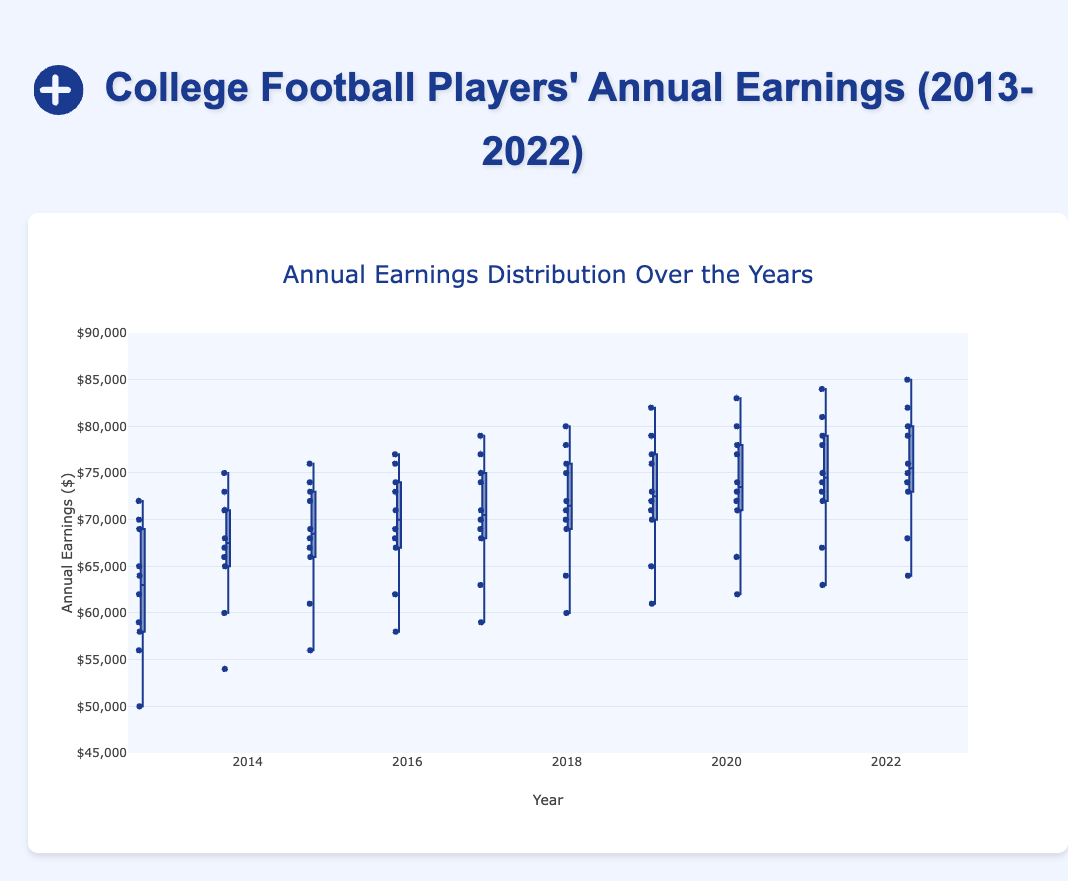What is the title of the figure? The title of the figure is found at the top. It reads "Annual Earnings Distribution Over the Years."
Answer: Annual Earnings Distribution Over the Years What is the range of the y-axis? The y-axis range is provided in the chart's layout and spans from a low value to a high value. In this case, it ranges from $45,000 to $90,000.
Answer: $45,000 to $90,000 How does the median annual earning for 2013 compare to 2022? The median is represented by the line inside each box. Viewing the boxes for 2013 and 2022, we can see that the median for 2013 is lower compared to 2022's median.
Answer: 2013 is lower than 2022 Which year has the highest upper whisker value? The upper whisker represents the maximum non-outlier value. By comparing all the upper whiskers, 2022 reaches the highest value.
Answer: 2022 What is the median annual earning for 2021? The median annual earning for each year is shown by the line inside each box. For 2021, the median is where the line divides the box.
Answer: $74000 Are the 2020 and 2021 interquartile ranges (IQR) overlapping? The IQR is the range between the first quartile (bottom edge of the box) and the third quartile (top edge of the box). By visually comparing the 2020 and 2021 boxes, we can see that they do overlap.
Answer: Yes What is the smallest annual earning recorded in 2013? The smallest earning is indicated by the bottom whisker of the 2013 box.
Answer: $50,000 What is the approximate median across all years from 2013 to 2022? Approximate medians can be visually averaged by looking at the middle lines inside each of the boxes. Assuming each median is roughly in the range of $60,000 to $80,000, the combined median would be around $70,000.
Answer: $70,000 Which year shows the greatest variability in earnings? Variability is indicated by the height of the boxes and whiskers. The year with the largest IQR and whisker spread appears to be 2022.
Answer: 2022 How does the 2015 average annual earning compare to 2018? While the box plot doesn't directly show means, we can infer averages from the medians and spread. 2018 likely has a higher average since its median and quartile values are consistently higher than those of 2015.
Answer: 2018 is higher 